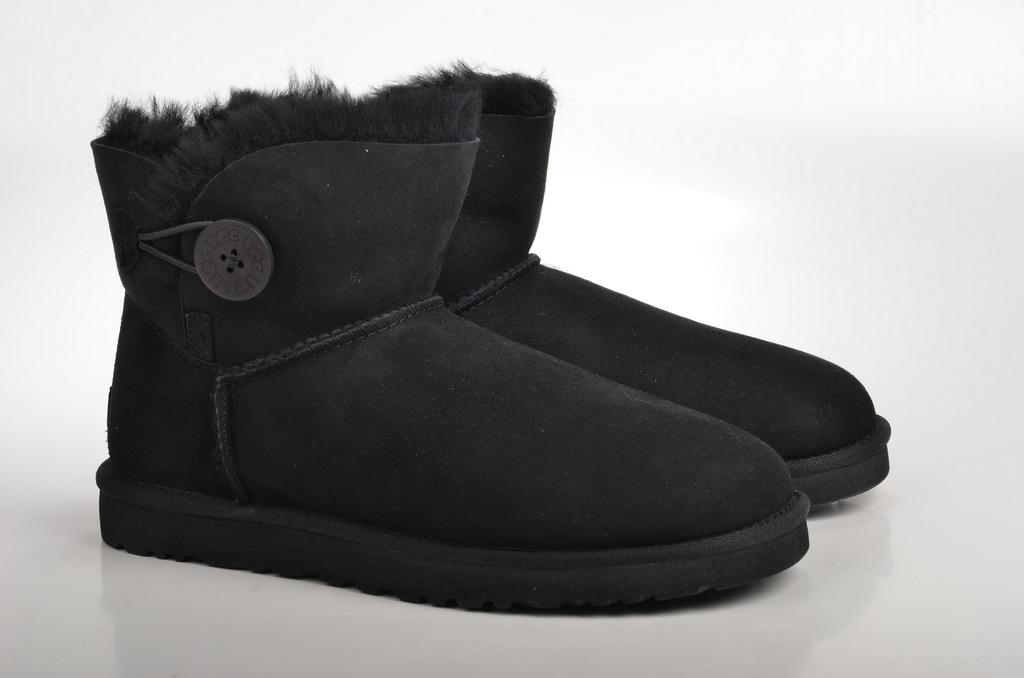What color is the footwear in the image? The footwear in the image is black. Where is the footwear located in the image? The footwear is on a surface. What color is the background of the image? The background of the image is white. How many dogs are visible in the image? There are no dogs present in the image. What time of day is depicted in the image? The time of day is not depicted in the image, as it does not contain any elements that would indicate the time. 